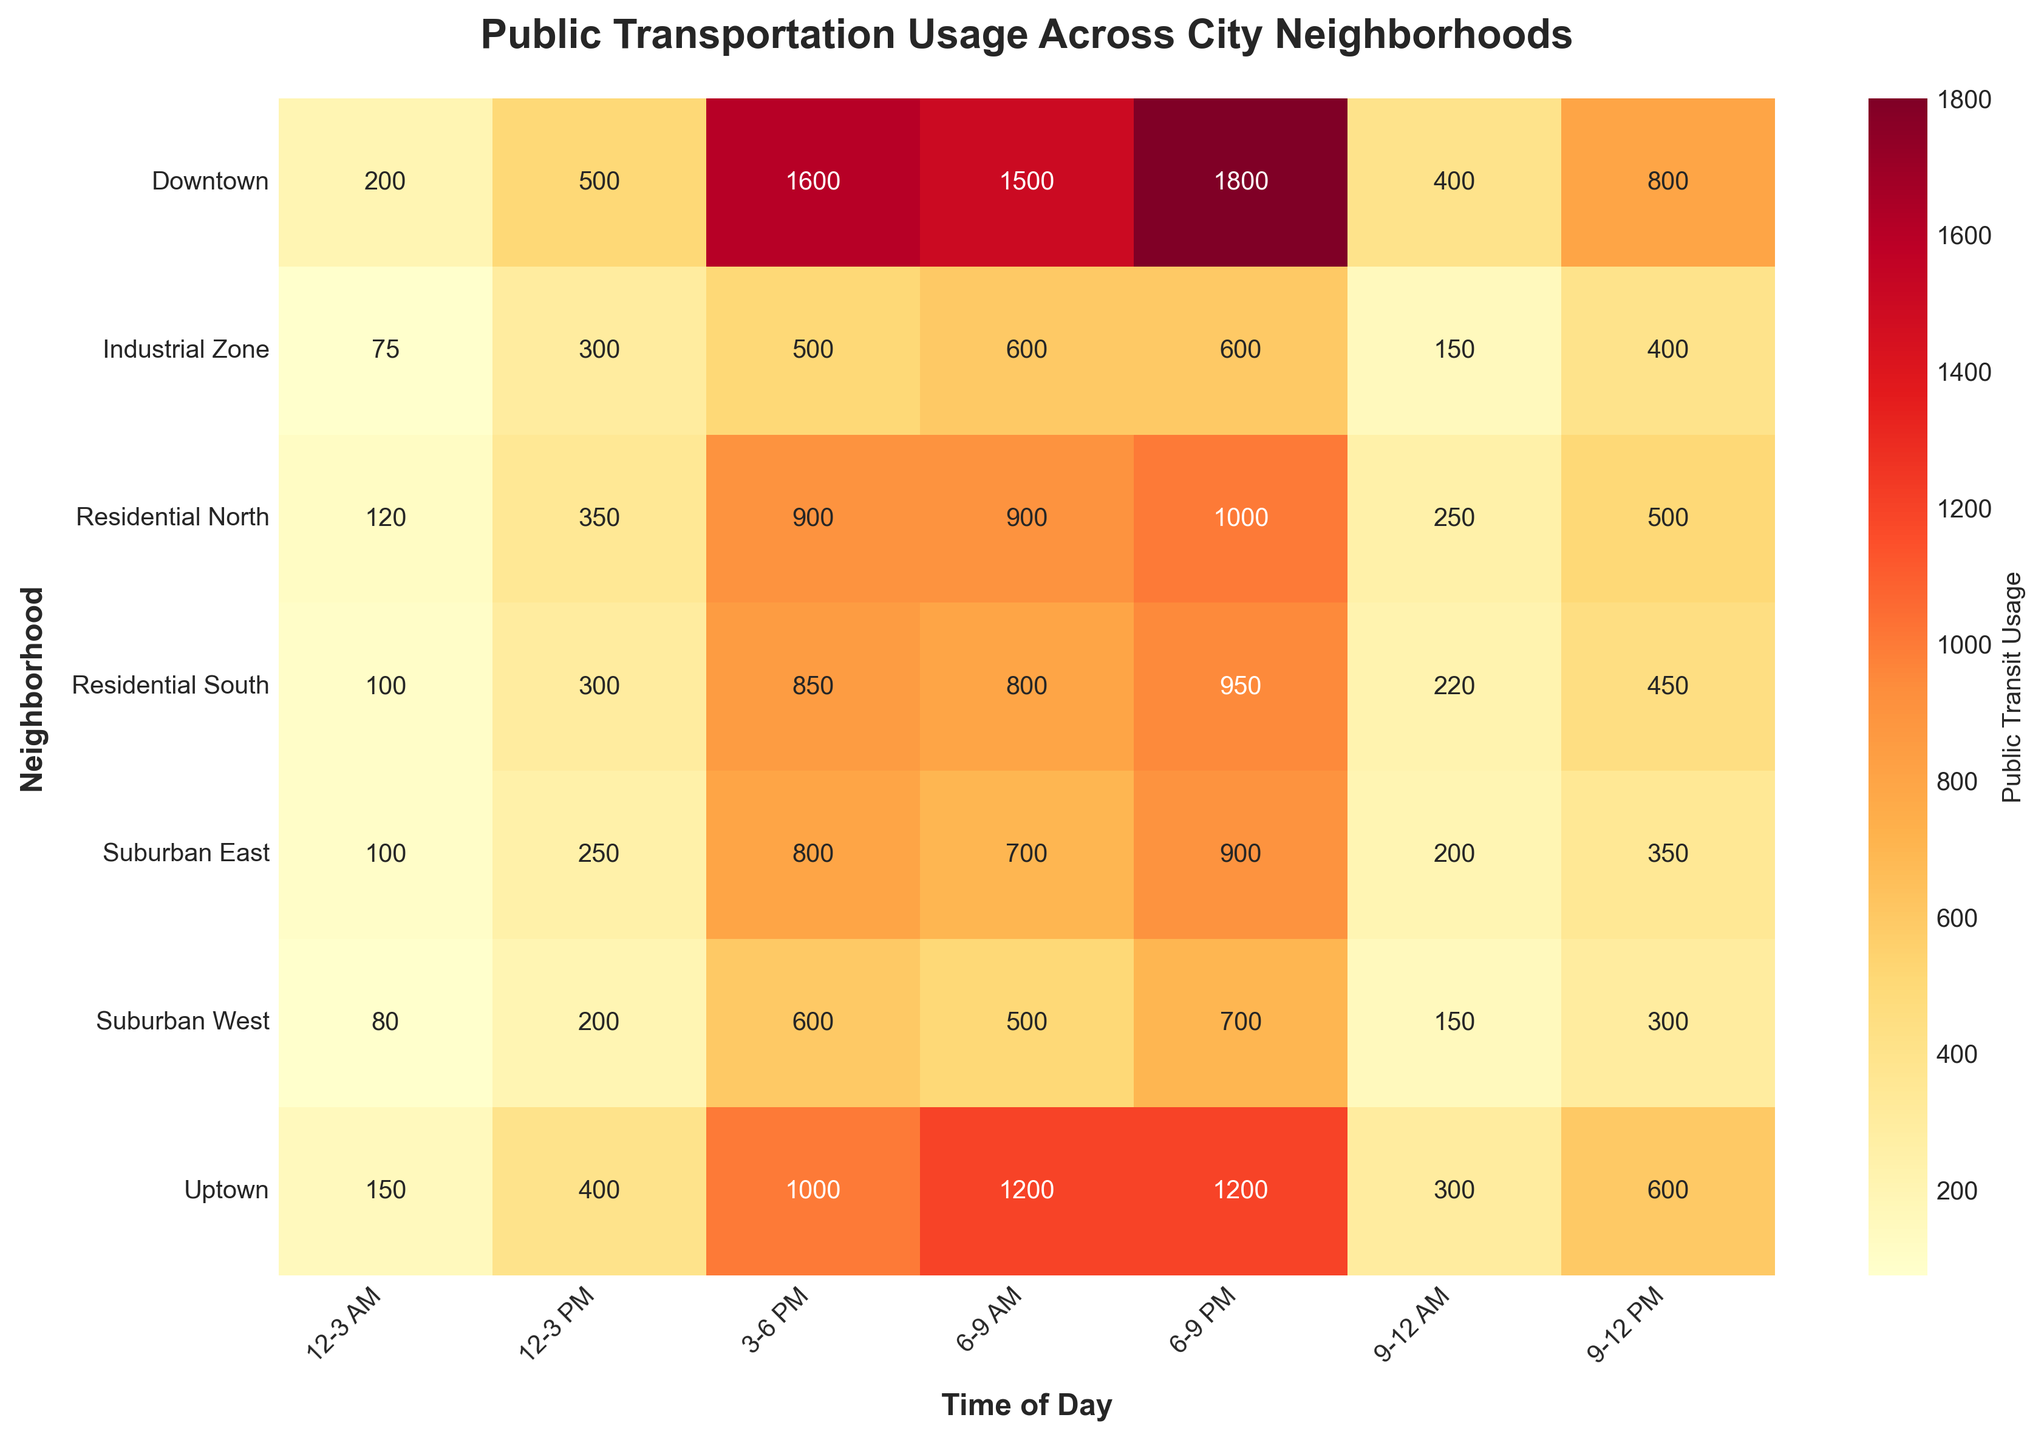What is the title of the heatmap? The title is located at the top of the heatmap and provides an overview of what the heatmap represents.
Answer: Public Transportation Usage Across City Neighborhoods Which neighborhood has the highest public transit usage in the 3-6 PM time slot? Look for the maximum value in the 3-6 PM column and identify the corresponding neighborhood.
Answer: Downtown How many neighborhoods have more than 1000 public transit usage in any time slot? Scan each column and count the unique neighborhoods where the value exceeds 1000 in any time slot.
Answer: Three (Downtown, Uptown, Residential North) What is the total public transit usage in Suburban West across all time slots? Add up all the values in the Suburban West row. (500 + 300 + 200 + 600 + 700 + 150 + 80) = 2530
Answer: 2530 Which time slot has the highest average public transit usage across all neighborhoods? For each time slot, sum up the public transit usage across all neighborhoods and then divide by the number of neighborhoods. Compare these average values to find the highest.
Answer: 6-9 PM Compare the public transit usage between Downtown and Industrial Zone during the 6-9 AM time slot. Which neighborhood has higher usage and by how much? Downtown's usage is 1500 and Industrial Zone's usage is 600. Subtract the two values to find the difference.
Answer: Downtown; 900 Which neighborhood has the least public transit usage during the 12-3 AM slot, and what is the usage? Identify the neighborhood with the minimum value in the 12-3 AM column.
Answer: Industrial Zone; 75 Calculate the ratio of public transit usage between Downtown and Uptown for the 9-12 PM slot. Divide the value of Downtown (800) by the value of Uptown (600) in the 9-12 PM slot. (800/600) = 1.33
Answer: 1.33 What is the difference in public transit usage between Residential North and Residential South during the 3-6 PM time slot? Subtract the usage of Residential South (850) from Residential North (900). (900 - 850) = 50
Answer: 50 In which neighborhood and time slot combination is the public transit usage exactly 250? Find the cell in the heatmap grid where the usage is 250 and note the corresponding neighborhood and time slot.
Answer: Suburban East, 12-3 PM 